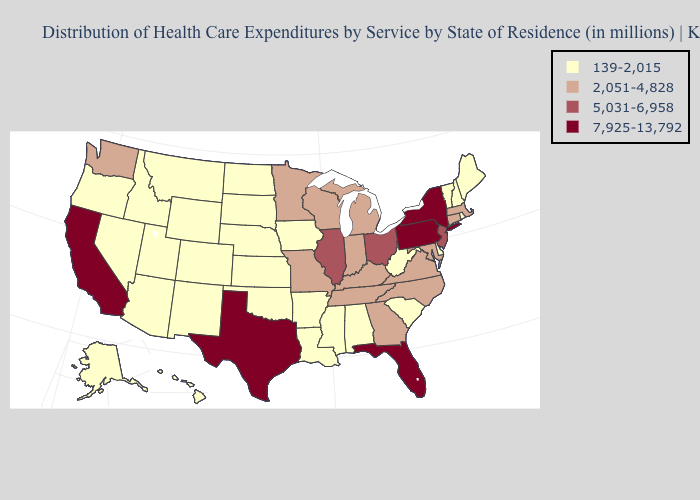Which states hav the highest value in the MidWest?
Concise answer only. Illinois, Ohio. Does Missouri have the same value as Minnesota?
Short answer required. Yes. What is the lowest value in the MidWest?
Write a very short answer. 139-2,015. Among the states that border Georgia , does South Carolina have the lowest value?
Write a very short answer. Yes. What is the highest value in the USA?
Be succinct. 7,925-13,792. What is the value of Missouri?
Short answer required. 2,051-4,828. Among the states that border South Dakota , does Minnesota have the highest value?
Concise answer only. Yes. Name the states that have a value in the range 139-2,015?
Short answer required. Alabama, Alaska, Arizona, Arkansas, Colorado, Delaware, Hawaii, Idaho, Iowa, Kansas, Louisiana, Maine, Mississippi, Montana, Nebraska, Nevada, New Hampshire, New Mexico, North Dakota, Oklahoma, Oregon, Rhode Island, South Carolina, South Dakota, Utah, Vermont, West Virginia, Wyoming. Does the map have missing data?
Be succinct. No. Which states hav the highest value in the South?
Give a very brief answer. Florida, Texas. Does Indiana have the lowest value in the MidWest?
Concise answer only. No. Name the states that have a value in the range 5,031-6,958?
Keep it brief. Illinois, New Jersey, Ohio. Among the states that border New Jersey , which have the highest value?
Be succinct. New York, Pennsylvania. Among the states that border Oklahoma , does Arkansas have the highest value?
Write a very short answer. No. Does Idaho have the highest value in the West?
Write a very short answer. No. 